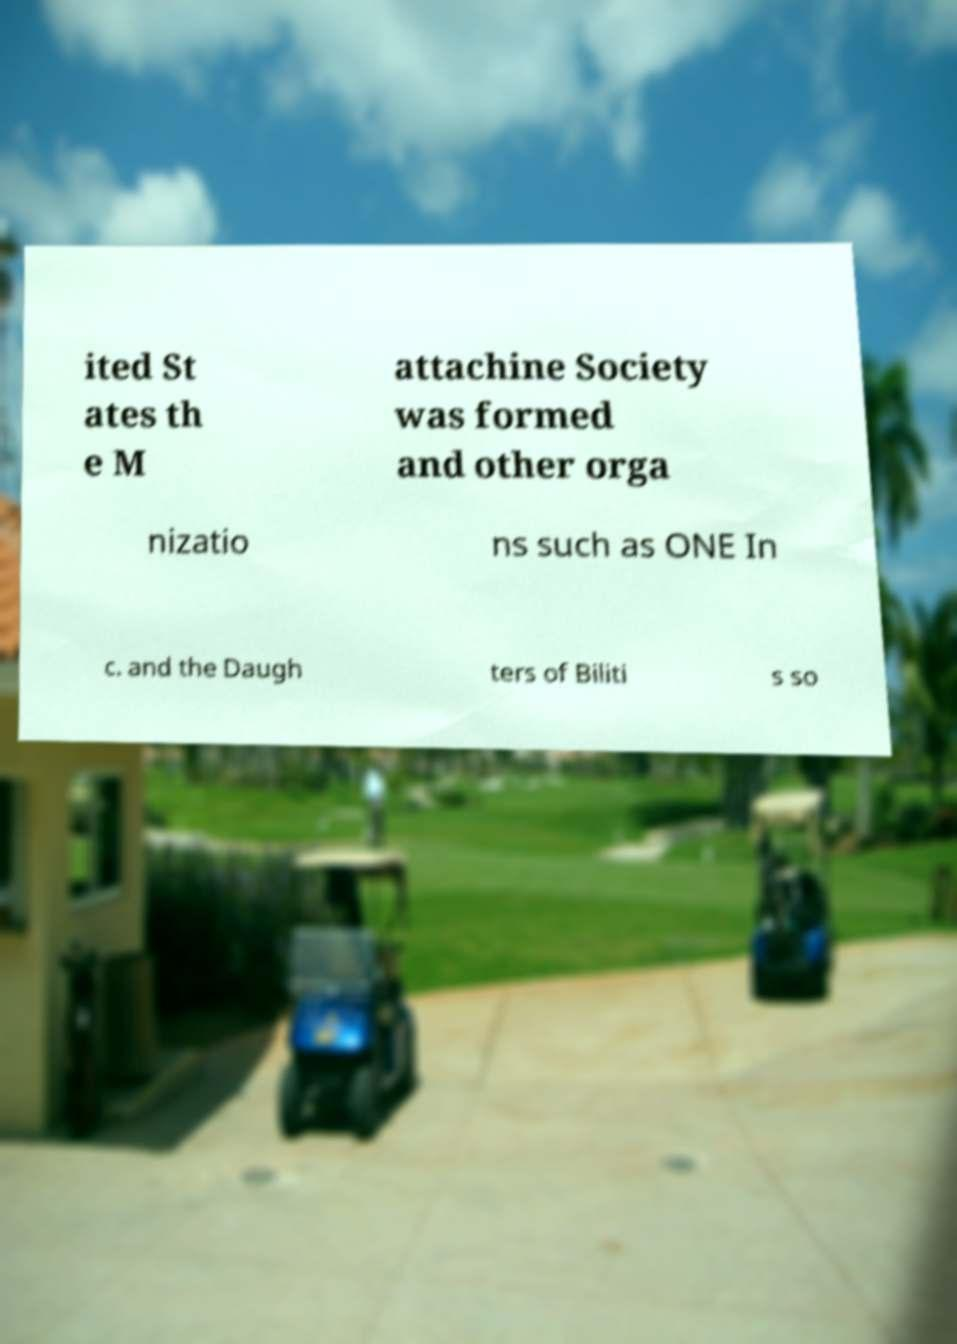For documentation purposes, I need the text within this image transcribed. Could you provide that? ited St ates th e M attachine Society was formed and other orga nizatio ns such as ONE In c. and the Daugh ters of Biliti s so 